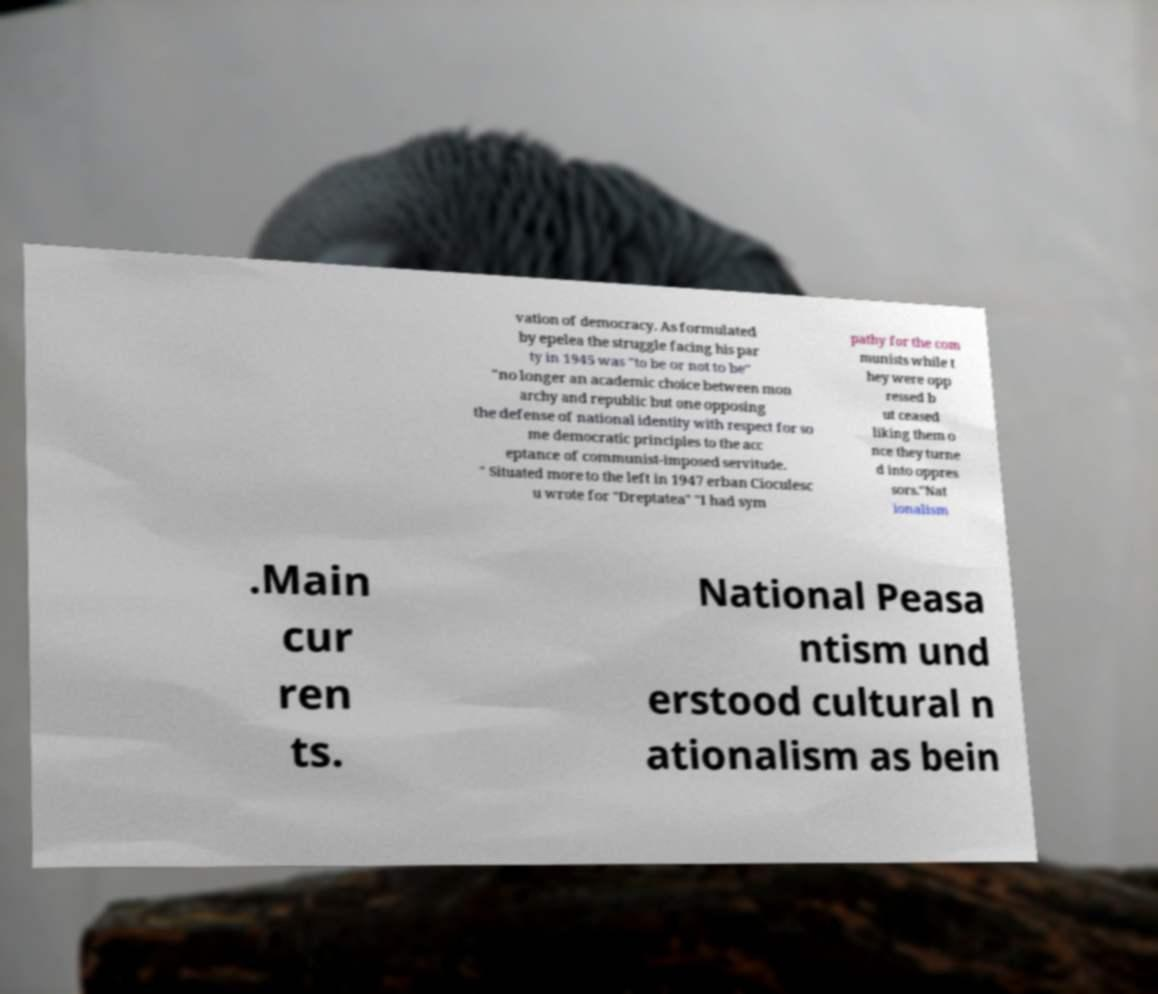What messages or text are displayed in this image? I need them in a readable, typed format. vation of democracy. As formulated by epelea the struggle facing his par ty in 1945 was "to be or not to be" "no longer an academic choice between mon archy and republic but one opposing the defense of national identity with respect for so me democratic principles to the acc eptance of communist-imposed servitude. " Situated more to the left in 1947 erban Cioculesc u wrote for "Dreptatea" "I had sym pathy for the com munists while t hey were opp ressed b ut ceased liking them o nce they turne d into oppres sors."Nat ionalism .Main cur ren ts. National Peasa ntism und erstood cultural n ationalism as bein 